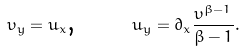Convert formula to latex. <formula><loc_0><loc_0><loc_500><loc_500>\upsilon _ { y } = u _ { x } \text {, \quad \ \ } u _ { y } = \partial _ { x } \frac { \upsilon ^ { \beta - 1 } } { \beta - 1 } .</formula> 